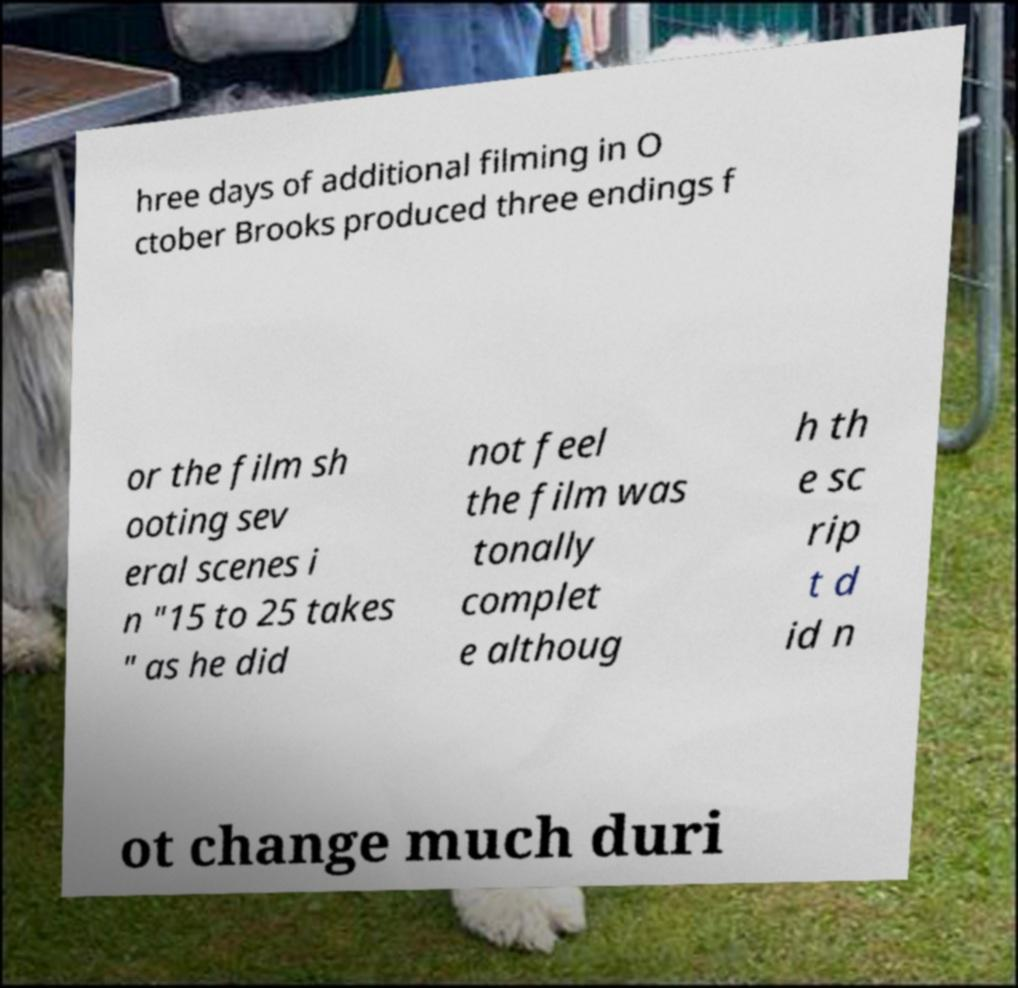Can you read and provide the text displayed in the image?This photo seems to have some interesting text. Can you extract and type it out for me? hree days of additional filming in O ctober Brooks produced three endings f or the film sh ooting sev eral scenes i n "15 to 25 takes " as he did not feel the film was tonally complet e althoug h th e sc rip t d id n ot change much duri 